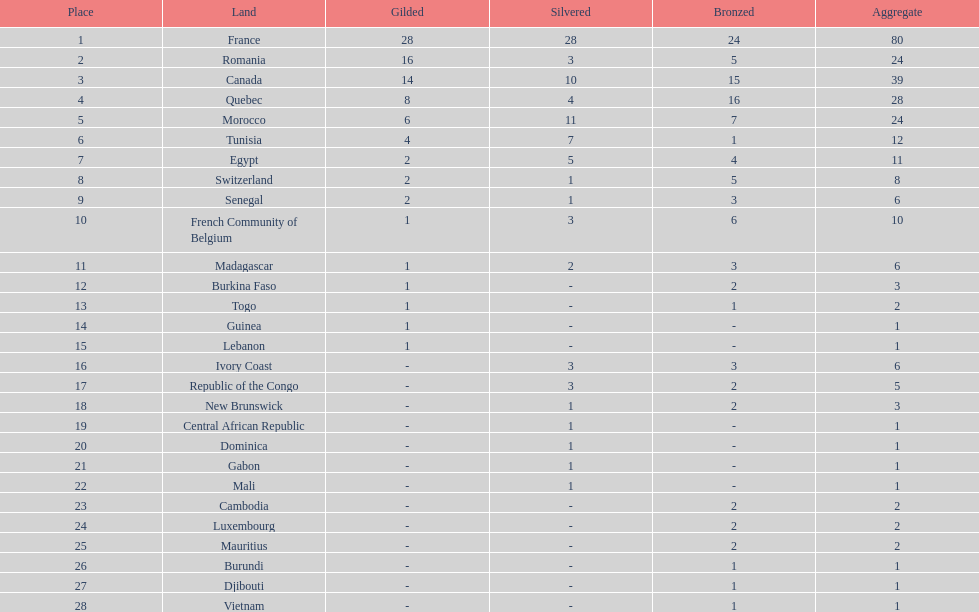Who placed in first according to medals? France. 